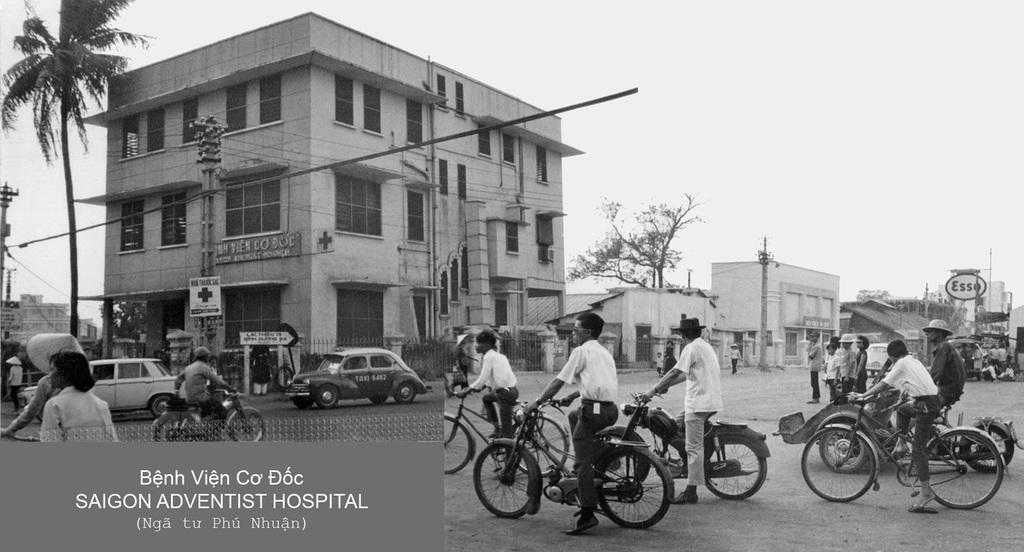What are the people in the image doing? The people in the image are riding bicycles. What type of vehicles are present in the image? There are bikes and cars in the image. What structures can be seen in the image? There is at least one building in the image. What type of vegetation is visible in the image? There are trees in the image. Where is the pocket located on the bicycle in the image? There is no pocket present on the bicycle in the image. Can you see a crown on the head of any person in the image? There is no crown visible on the head of any person in the image. 